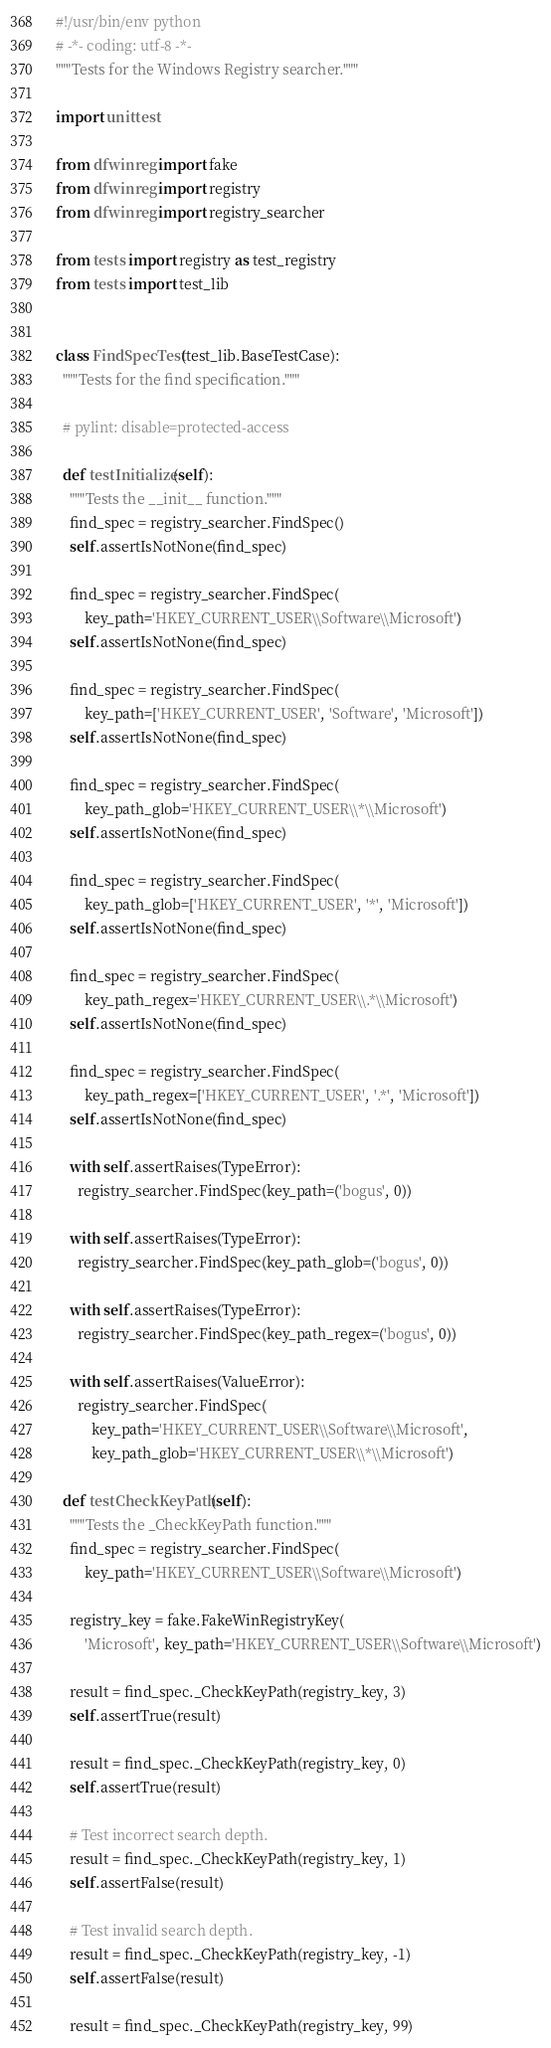<code> <loc_0><loc_0><loc_500><loc_500><_Python_>#!/usr/bin/env python
# -*- coding: utf-8 -*-
"""Tests for the Windows Registry searcher."""

import unittest

from dfwinreg import fake
from dfwinreg import registry
from dfwinreg import registry_searcher

from tests import registry as test_registry
from tests import test_lib


class FindSpecTest(test_lib.BaseTestCase):
  """Tests for the find specification."""

  # pylint: disable=protected-access

  def testInitialize(self):
    """Tests the __init__ function."""
    find_spec = registry_searcher.FindSpec()
    self.assertIsNotNone(find_spec)

    find_spec = registry_searcher.FindSpec(
        key_path='HKEY_CURRENT_USER\\Software\\Microsoft')
    self.assertIsNotNone(find_spec)

    find_spec = registry_searcher.FindSpec(
        key_path=['HKEY_CURRENT_USER', 'Software', 'Microsoft'])
    self.assertIsNotNone(find_spec)

    find_spec = registry_searcher.FindSpec(
        key_path_glob='HKEY_CURRENT_USER\\*\\Microsoft')
    self.assertIsNotNone(find_spec)

    find_spec = registry_searcher.FindSpec(
        key_path_glob=['HKEY_CURRENT_USER', '*', 'Microsoft'])
    self.assertIsNotNone(find_spec)

    find_spec = registry_searcher.FindSpec(
        key_path_regex='HKEY_CURRENT_USER\\.*\\Microsoft')
    self.assertIsNotNone(find_spec)

    find_spec = registry_searcher.FindSpec(
        key_path_regex=['HKEY_CURRENT_USER', '.*', 'Microsoft'])
    self.assertIsNotNone(find_spec)

    with self.assertRaises(TypeError):
      registry_searcher.FindSpec(key_path=('bogus', 0))

    with self.assertRaises(TypeError):
      registry_searcher.FindSpec(key_path_glob=('bogus', 0))

    with self.assertRaises(TypeError):
      registry_searcher.FindSpec(key_path_regex=('bogus', 0))

    with self.assertRaises(ValueError):
      registry_searcher.FindSpec(
          key_path='HKEY_CURRENT_USER\\Software\\Microsoft',
          key_path_glob='HKEY_CURRENT_USER\\*\\Microsoft')

  def testCheckKeyPath(self):
    """Tests the _CheckKeyPath function."""
    find_spec = registry_searcher.FindSpec(
        key_path='HKEY_CURRENT_USER\\Software\\Microsoft')

    registry_key = fake.FakeWinRegistryKey(
        'Microsoft', key_path='HKEY_CURRENT_USER\\Software\\Microsoft')

    result = find_spec._CheckKeyPath(registry_key, 3)
    self.assertTrue(result)

    result = find_spec._CheckKeyPath(registry_key, 0)
    self.assertTrue(result)

    # Test incorrect search depth.
    result = find_spec._CheckKeyPath(registry_key, 1)
    self.assertFalse(result)

    # Test invalid search depth.
    result = find_spec._CheckKeyPath(registry_key, -1)
    self.assertFalse(result)

    result = find_spec._CheckKeyPath(registry_key, 99)</code> 